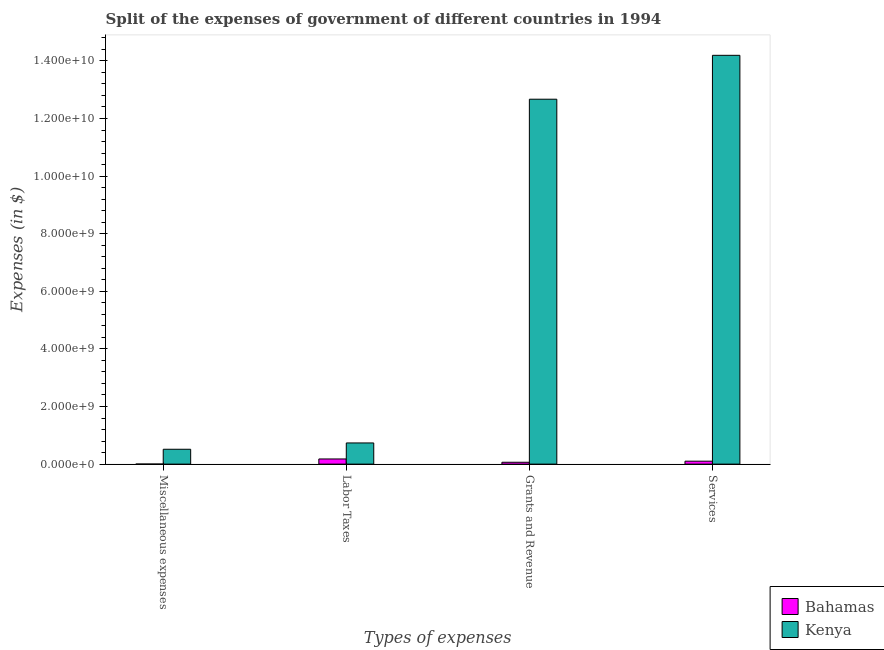How many groups of bars are there?
Your response must be concise. 4. Are the number of bars on each tick of the X-axis equal?
Your answer should be compact. Yes. How many bars are there on the 2nd tick from the left?
Your answer should be very brief. 2. What is the label of the 3rd group of bars from the left?
Give a very brief answer. Grants and Revenue. What is the amount spent on labor taxes in Bahamas?
Ensure brevity in your answer.  1.79e+08. Across all countries, what is the maximum amount spent on services?
Offer a terse response. 1.42e+1. Across all countries, what is the minimum amount spent on labor taxes?
Give a very brief answer. 1.79e+08. In which country was the amount spent on labor taxes maximum?
Make the answer very short. Kenya. In which country was the amount spent on services minimum?
Offer a very short reply. Bahamas. What is the total amount spent on labor taxes in the graph?
Keep it short and to the point. 9.14e+08. What is the difference between the amount spent on services in Kenya and that in Bahamas?
Your answer should be compact. 1.41e+1. What is the difference between the amount spent on labor taxes in Bahamas and the amount spent on miscellaneous expenses in Kenya?
Offer a very short reply. -3.37e+08. What is the average amount spent on services per country?
Your answer should be compact. 7.15e+09. What is the difference between the amount spent on services and amount spent on miscellaneous expenses in Kenya?
Offer a very short reply. 1.37e+1. In how many countries, is the amount spent on grants and revenue greater than 14400000000 $?
Your answer should be very brief. 0. What is the ratio of the amount spent on miscellaneous expenses in Bahamas to that in Kenya?
Provide a succinct answer. 0. Is the amount spent on services in Kenya less than that in Bahamas?
Your response must be concise. No. Is the difference between the amount spent on services in Kenya and Bahamas greater than the difference between the amount spent on labor taxes in Kenya and Bahamas?
Provide a short and direct response. Yes. What is the difference between the highest and the second highest amount spent on miscellaneous expenses?
Ensure brevity in your answer.  5.14e+08. What is the difference between the highest and the lowest amount spent on labor taxes?
Provide a succinct answer. 5.56e+08. In how many countries, is the amount spent on miscellaneous expenses greater than the average amount spent on miscellaneous expenses taken over all countries?
Your answer should be very brief. 1. Is it the case that in every country, the sum of the amount spent on grants and revenue and amount spent on labor taxes is greater than the sum of amount spent on miscellaneous expenses and amount spent on services?
Your response must be concise. No. What does the 2nd bar from the left in Services represents?
Your response must be concise. Kenya. What does the 1st bar from the right in Labor Taxes represents?
Ensure brevity in your answer.  Kenya. Is it the case that in every country, the sum of the amount spent on miscellaneous expenses and amount spent on labor taxes is greater than the amount spent on grants and revenue?
Provide a short and direct response. No. Are all the bars in the graph horizontal?
Keep it short and to the point. No. What is the difference between two consecutive major ticks on the Y-axis?
Your response must be concise. 2.00e+09. Does the graph contain grids?
Provide a succinct answer. No. How many legend labels are there?
Your answer should be compact. 2. What is the title of the graph?
Give a very brief answer. Split of the expenses of government of different countries in 1994. What is the label or title of the X-axis?
Your response must be concise. Types of expenses. What is the label or title of the Y-axis?
Provide a succinct answer. Expenses (in $). What is the Expenses (in $) in Bahamas in Miscellaneous expenses?
Give a very brief answer. 1.80e+06. What is the Expenses (in $) of Kenya in Miscellaneous expenses?
Keep it short and to the point. 5.16e+08. What is the Expenses (in $) in Bahamas in Labor Taxes?
Give a very brief answer. 1.79e+08. What is the Expenses (in $) in Kenya in Labor Taxes?
Offer a very short reply. 7.35e+08. What is the Expenses (in $) in Bahamas in Grants and Revenue?
Provide a short and direct response. 6.45e+07. What is the Expenses (in $) of Kenya in Grants and Revenue?
Your response must be concise. 1.27e+1. What is the Expenses (in $) in Bahamas in Services?
Provide a short and direct response. 1.02e+08. What is the Expenses (in $) of Kenya in Services?
Offer a terse response. 1.42e+1. Across all Types of expenses, what is the maximum Expenses (in $) of Bahamas?
Keep it short and to the point. 1.79e+08. Across all Types of expenses, what is the maximum Expenses (in $) of Kenya?
Your answer should be compact. 1.42e+1. Across all Types of expenses, what is the minimum Expenses (in $) in Bahamas?
Provide a short and direct response. 1.80e+06. Across all Types of expenses, what is the minimum Expenses (in $) in Kenya?
Provide a succinct answer. 5.16e+08. What is the total Expenses (in $) in Bahamas in the graph?
Make the answer very short. 3.47e+08. What is the total Expenses (in $) of Kenya in the graph?
Provide a short and direct response. 2.81e+1. What is the difference between the Expenses (in $) of Bahamas in Miscellaneous expenses and that in Labor Taxes?
Ensure brevity in your answer.  -1.77e+08. What is the difference between the Expenses (in $) in Kenya in Miscellaneous expenses and that in Labor Taxes?
Give a very brief answer. -2.19e+08. What is the difference between the Expenses (in $) in Bahamas in Miscellaneous expenses and that in Grants and Revenue?
Ensure brevity in your answer.  -6.27e+07. What is the difference between the Expenses (in $) in Kenya in Miscellaneous expenses and that in Grants and Revenue?
Your answer should be very brief. -1.22e+1. What is the difference between the Expenses (in $) of Bahamas in Miscellaneous expenses and that in Services?
Offer a terse response. -1.00e+08. What is the difference between the Expenses (in $) in Kenya in Miscellaneous expenses and that in Services?
Your answer should be very brief. -1.37e+1. What is the difference between the Expenses (in $) of Bahamas in Labor Taxes and that in Grants and Revenue?
Your response must be concise. 1.14e+08. What is the difference between the Expenses (in $) of Kenya in Labor Taxes and that in Grants and Revenue?
Offer a terse response. -1.19e+1. What is the difference between the Expenses (in $) of Bahamas in Labor Taxes and that in Services?
Ensure brevity in your answer.  7.70e+07. What is the difference between the Expenses (in $) of Kenya in Labor Taxes and that in Services?
Provide a short and direct response. -1.35e+1. What is the difference between the Expenses (in $) of Bahamas in Grants and Revenue and that in Services?
Give a very brief answer. -3.75e+07. What is the difference between the Expenses (in $) of Kenya in Grants and Revenue and that in Services?
Ensure brevity in your answer.  -1.52e+09. What is the difference between the Expenses (in $) of Bahamas in Miscellaneous expenses and the Expenses (in $) of Kenya in Labor Taxes?
Your response must be concise. -7.33e+08. What is the difference between the Expenses (in $) in Bahamas in Miscellaneous expenses and the Expenses (in $) in Kenya in Grants and Revenue?
Ensure brevity in your answer.  -1.27e+1. What is the difference between the Expenses (in $) in Bahamas in Miscellaneous expenses and the Expenses (in $) in Kenya in Services?
Your response must be concise. -1.42e+1. What is the difference between the Expenses (in $) in Bahamas in Labor Taxes and the Expenses (in $) in Kenya in Grants and Revenue?
Your answer should be very brief. -1.25e+1. What is the difference between the Expenses (in $) of Bahamas in Labor Taxes and the Expenses (in $) of Kenya in Services?
Your response must be concise. -1.40e+1. What is the difference between the Expenses (in $) in Bahamas in Grants and Revenue and the Expenses (in $) in Kenya in Services?
Your answer should be compact. -1.41e+1. What is the average Expenses (in $) of Bahamas per Types of expenses?
Ensure brevity in your answer.  8.68e+07. What is the average Expenses (in $) of Kenya per Types of expenses?
Ensure brevity in your answer.  7.03e+09. What is the difference between the Expenses (in $) of Bahamas and Expenses (in $) of Kenya in Miscellaneous expenses?
Make the answer very short. -5.14e+08. What is the difference between the Expenses (in $) of Bahamas and Expenses (in $) of Kenya in Labor Taxes?
Offer a terse response. -5.56e+08. What is the difference between the Expenses (in $) of Bahamas and Expenses (in $) of Kenya in Grants and Revenue?
Your response must be concise. -1.26e+1. What is the difference between the Expenses (in $) in Bahamas and Expenses (in $) in Kenya in Services?
Give a very brief answer. -1.41e+1. What is the ratio of the Expenses (in $) in Bahamas in Miscellaneous expenses to that in Labor Taxes?
Your answer should be very brief. 0.01. What is the ratio of the Expenses (in $) of Kenya in Miscellaneous expenses to that in Labor Taxes?
Offer a terse response. 0.7. What is the ratio of the Expenses (in $) in Bahamas in Miscellaneous expenses to that in Grants and Revenue?
Your answer should be very brief. 0.03. What is the ratio of the Expenses (in $) in Kenya in Miscellaneous expenses to that in Grants and Revenue?
Offer a terse response. 0.04. What is the ratio of the Expenses (in $) in Bahamas in Miscellaneous expenses to that in Services?
Keep it short and to the point. 0.02. What is the ratio of the Expenses (in $) of Kenya in Miscellaneous expenses to that in Services?
Offer a very short reply. 0.04. What is the ratio of the Expenses (in $) of Bahamas in Labor Taxes to that in Grants and Revenue?
Keep it short and to the point. 2.78. What is the ratio of the Expenses (in $) in Kenya in Labor Taxes to that in Grants and Revenue?
Your answer should be compact. 0.06. What is the ratio of the Expenses (in $) of Bahamas in Labor Taxes to that in Services?
Provide a succinct answer. 1.75. What is the ratio of the Expenses (in $) in Kenya in Labor Taxes to that in Services?
Offer a terse response. 0.05. What is the ratio of the Expenses (in $) in Bahamas in Grants and Revenue to that in Services?
Offer a terse response. 0.63. What is the ratio of the Expenses (in $) of Kenya in Grants and Revenue to that in Services?
Provide a succinct answer. 0.89. What is the difference between the highest and the second highest Expenses (in $) in Bahamas?
Offer a very short reply. 7.70e+07. What is the difference between the highest and the second highest Expenses (in $) in Kenya?
Make the answer very short. 1.52e+09. What is the difference between the highest and the lowest Expenses (in $) of Bahamas?
Your answer should be very brief. 1.77e+08. What is the difference between the highest and the lowest Expenses (in $) in Kenya?
Provide a short and direct response. 1.37e+1. 